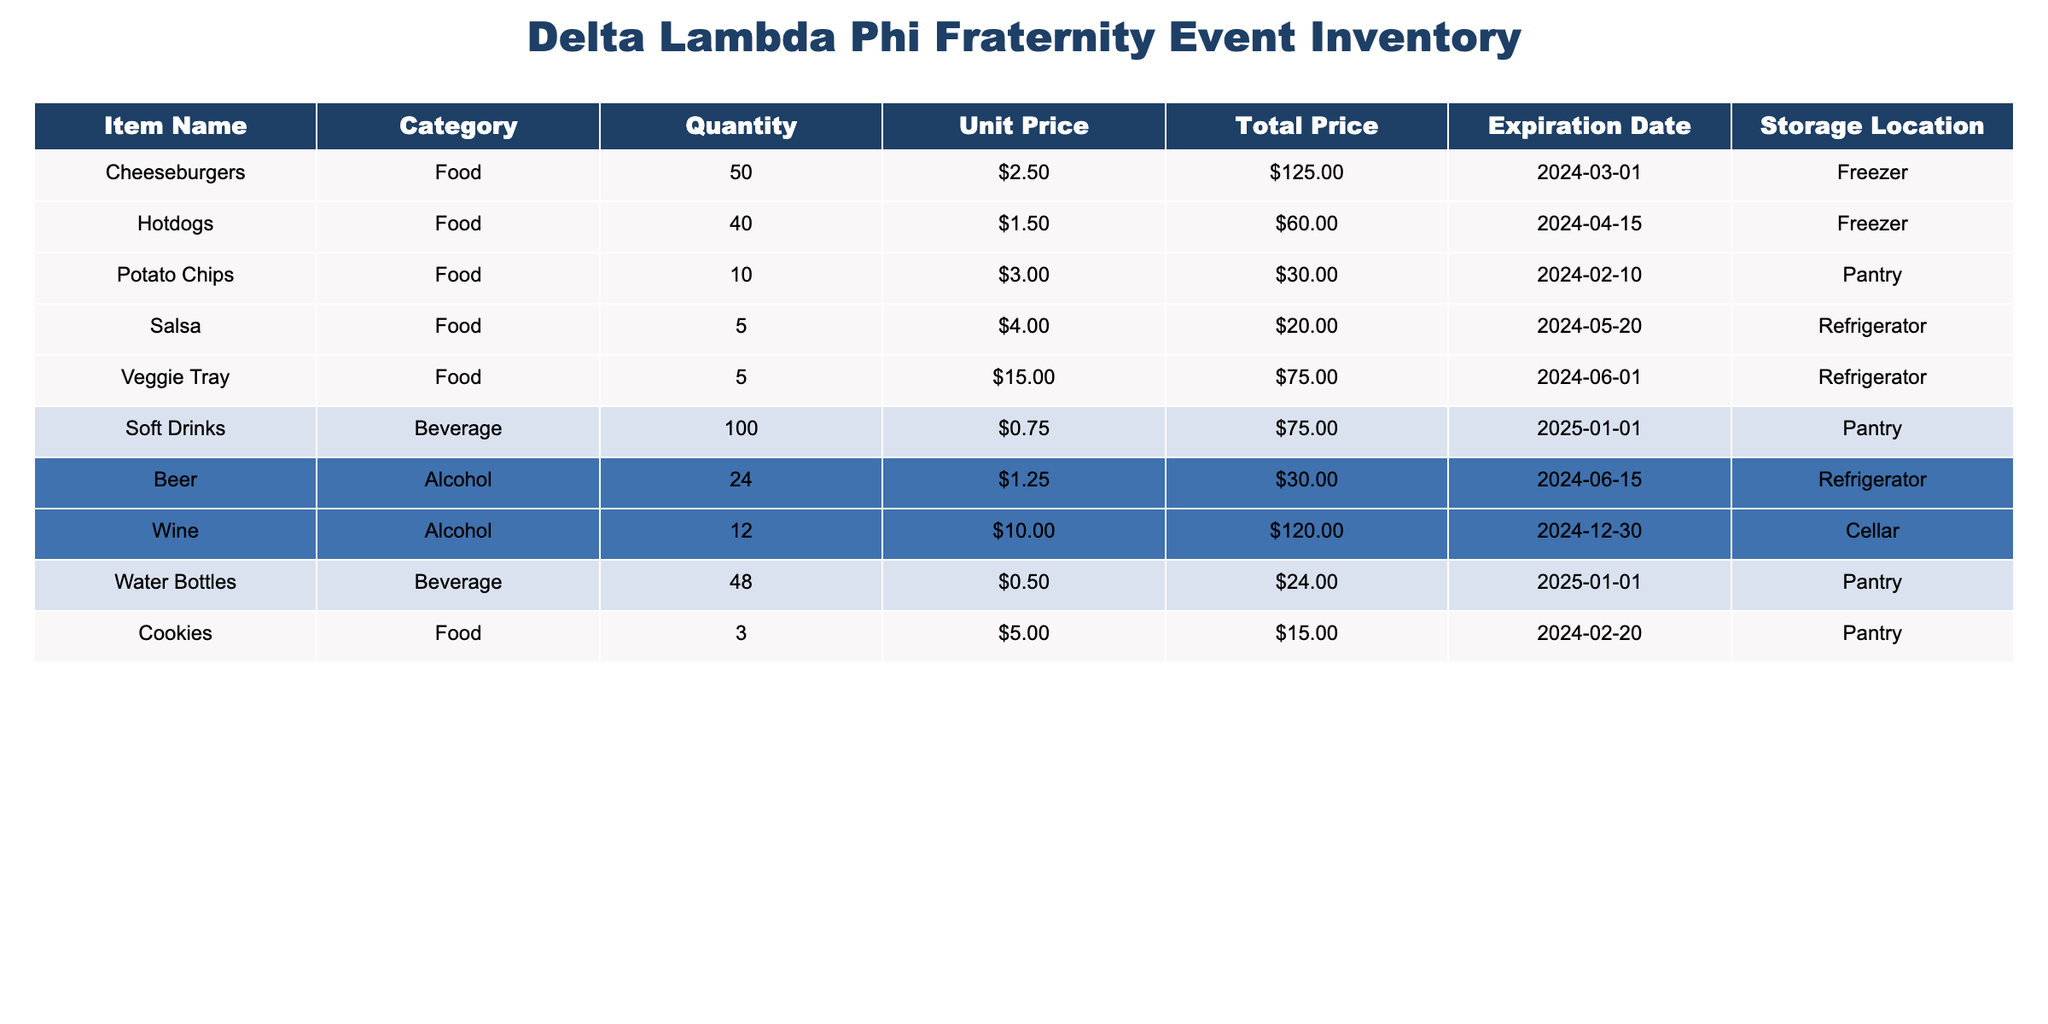What is the total quantity of food items available? To find the total quantity of food items, add the quantities of all food items listed in the table: 50 (Cheeseburgers) + 40 (Hotdogs) + 10 (Potato Chips) + 5 (Salsa) + 5 (Veggie Tray) + 3 (Cookies) = 113.
Answer: 113 What is the total price of beverages? The total price of beverages is calculated by summing the total prices of the Soft Drinks and Water Bottles. It is 75.00 (Soft Drinks) + 24.00 (Water Bottles) = 99.00.
Answer: 99.00 Is there any item that expires in the next month? To determine if an item expires in the next month, check the expiration dates. The items with expiration dates before the end of the next month are Potato Chips (2024-02-10) and Cookies (2024-02-20), so the answer is yes.
Answer: Yes What is the average unit price of food items? To calculate the average unit price of food items, first, find the unit prices: 2.50 (Cheeseburgers) + 1.50 (Hotdogs) + 3.00 (Potato Chips) + 4.00 (Salsa) + 15.00 (Veggie Tray) + 5.00 (Cookies) = 31.00. There are 6 food items, so the average is 31.00 / 6 ≈ 5.17.
Answer: 5.17 Are there more bottles of water than hotdogs? The quantity of Water Bottles is 48 and Hotdogs is 40. Since 48 is greater than 40, the answer is yes.
Answer: Yes What is the total price of all alcohol items combined? To find the total price of all alcohol items, sum the prices of Beer (30.00) and Wine (120.00). Therefore, it is 30.00 + 120.00 = 150.00.
Answer: 150.00 How many food items have an expiration date after June 1, 2024? The food items with expiration dates after June 1, 2024, are Hotdogs (2024-04-15), Salsa (2024-05-20), and Veggie Tray (2024-06-01) which is equal to 3.
Answer: 3 What is the difference in total price between the most expensive and least expensive food item? The total price of the most expensive food item (Veggie Tray, 75.00) minus the total price of the least expensive food item (Cookies, 15.00) gives a difference of 75.00 - 15.00 = 60.00.
Answer: 60.00 How many total items do we have in inventory? To find the total items in inventory, sum the quantity of all items listed: 50 + 40 + 10 + 5 + 5 + 100 + 24 + 12 + 48 + 3 = 297.
Answer: 297 